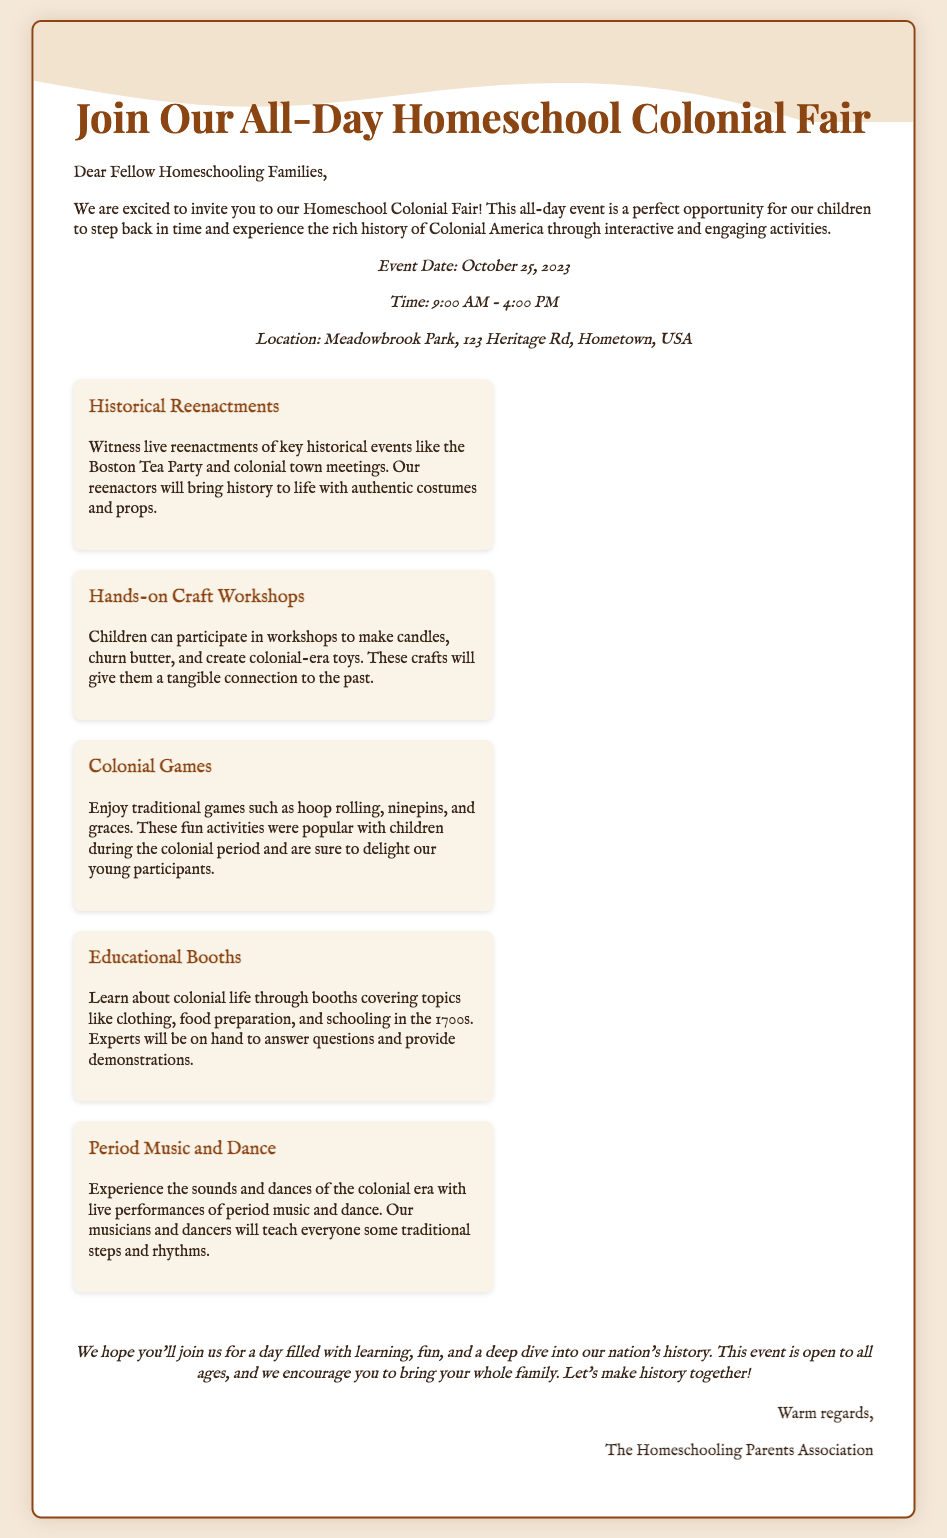What is the date of the event? The event date is explicitly mentioned in the document as October 25, 2023.
Answer: October 25, 2023 What time does the event start? The start time is stated in the document under the date and time section as 9:00 AM.
Answer: 9:00 AM What is one of the highlights of the fair? The document lists multiple highlights, one of which is "Historical Reenactments."
Answer: Historical Reenactments Where is the event located? The location can be found in the document, specifically in the location section as Meadowbrook Park, 123 Heritage Rd, Hometown, USA.
Answer: Meadowbrook Park, 123 Heritage Rd, Hometown, USA What type of workshops will be available? The document mentions "Hands-on Craft Workshops" that children can participate in.
Answer: Hands-on Craft Workshops Why should families attend the fair? The document states the event offers a day filled with learning, fun, and a deep dive into our nation's history.
Answer: Learning, fun, history How does the card sign off? The closing is mentioned along with a warm sign-off from the Homeschooling Parents Association.
Answer: Warm regards Which group is organizing the event? The signature at the end of the document indicates that "The Homeschooling Parents Association" is organizing the event.
Answer: The Homeschooling Parents Association 